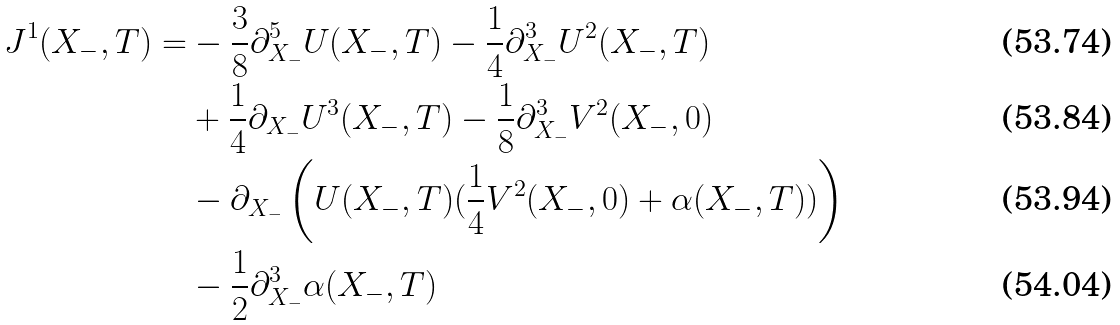<formula> <loc_0><loc_0><loc_500><loc_500>J ^ { 1 } ( X _ { - } , T ) = & - \frac { 3 } { 8 } \partial _ { X _ { - } } ^ { 5 } U ( X _ { - } , T ) - \frac { 1 } { 4 } \partial _ { X _ { - } } ^ { 3 } U ^ { 2 } ( X _ { - } , T ) \\ & + \frac { 1 } { 4 } \partial _ { X _ { - } } U ^ { 3 } ( X _ { - } , T ) - \frac { 1 } { 8 } \partial _ { X _ { - } } ^ { 3 } V ^ { 2 } ( X _ { - } , 0 ) \\ & - \partial _ { X _ { - } } \left ( U ( X _ { - } , T ) ( \frac { 1 } { 4 } V ^ { 2 } ( X _ { - } , 0 ) + \alpha ( X _ { - } , T ) ) \right ) \\ & - \frac { 1 } { 2 } \partial _ { X _ { - } } ^ { 3 } \alpha ( X _ { - } , T )</formula> 